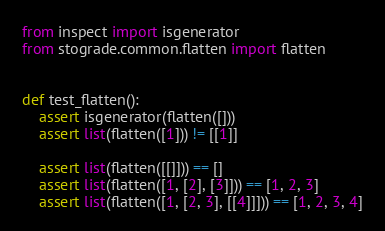<code> <loc_0><loc_0><loc_500><loc_500><_Python_>from inspect import isgenerator
from stograde.common.flatten import flatten


def test_flatten():
    assert isgenerator(flatten([]))
    assert list(flatten([1])) != [[1]]

    assert list(flatten([[]])) == []
    assert list(flatten([1, [2], [3]])) == [1, 2, 3]
    assert list(flatten([1, [2, 3], [[4]]])) == [1, 2, 3, 4]
</code> 